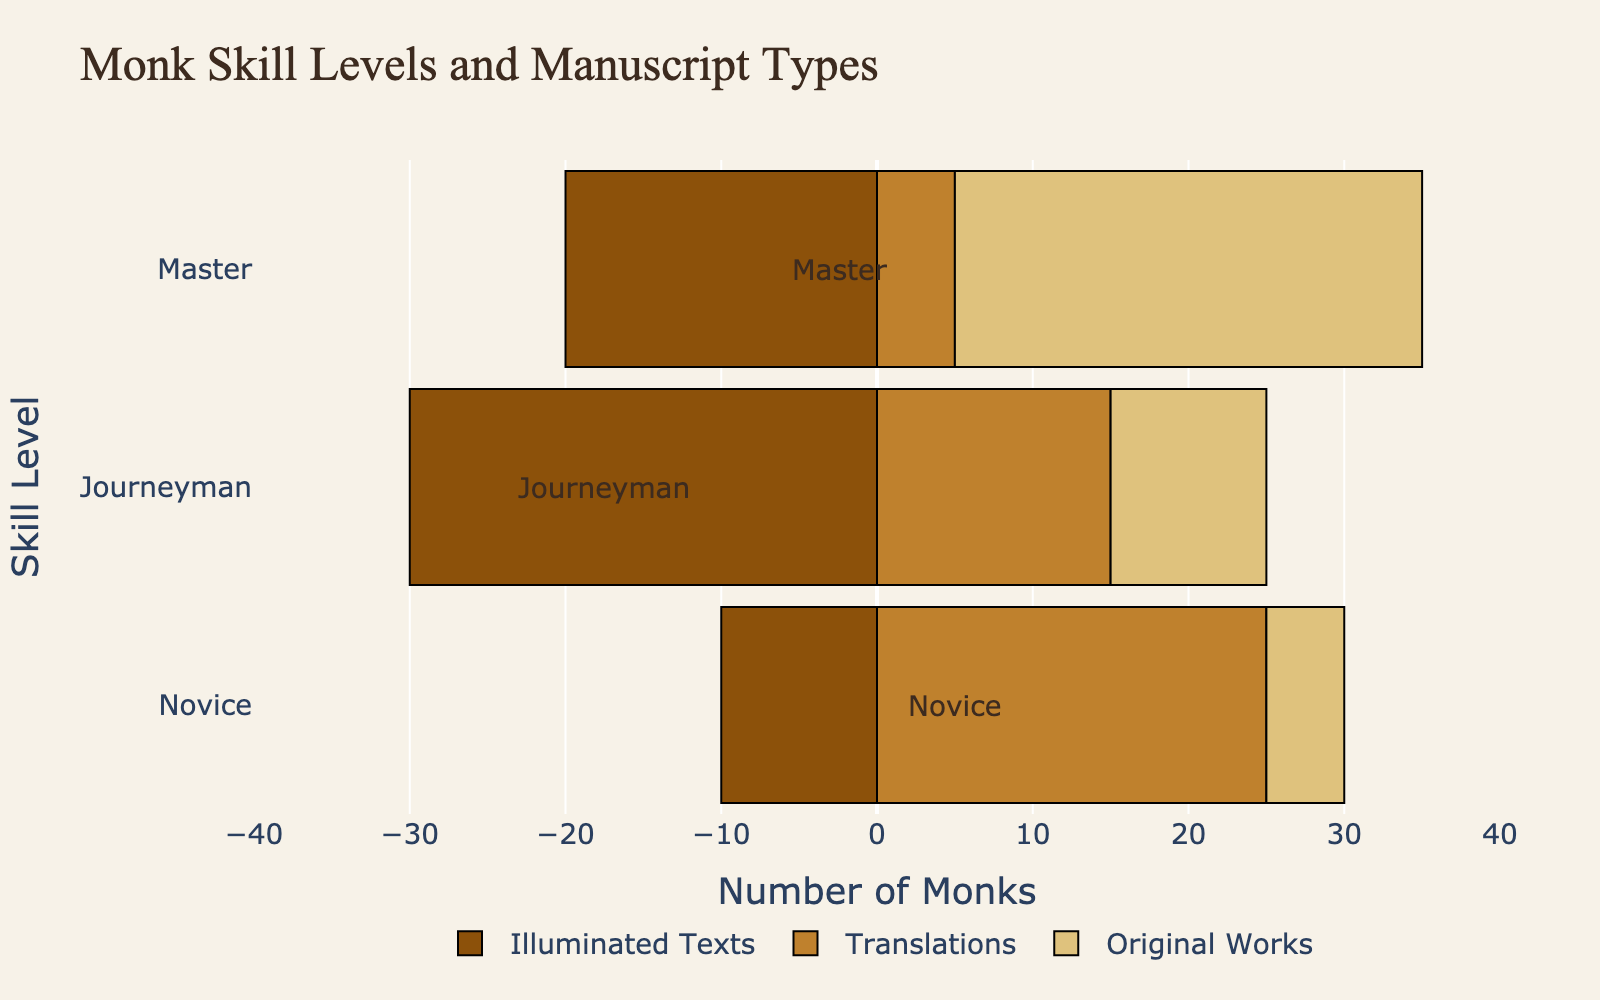Which skill level group works on the most original works? Looking at the bars for Original Works, the Master skill level has the longest bar, indicating they work on the most original works.
Answer: Master Among novices, which type of manuscript do they work on the most? For novices, the longest bar is for Translations, indicating it is the type of manuscript they work on the most.
Answer: Translations Comparing journeymen and masters, who works less on translations? The bar for Translations for Masters is shorter than that for Journeymen, indicating Masters work less on translations.
Answer: Masters How many monks in total work on illuminated texts? Sum the numbers for Illuminated Texts: 10 (Novice) + 30 (Journeyman) + 20 (Master) = 60 monks in total.
Answer: 60 What’s the difference in the number of monks working on translations between novices and journeymen? The number of monks working on Translations for novices is 25 and for journeymen is 15, so the difference is 25 - 15 = 10 monks.
Answer: 10 Which category has the smallest total number of monks across all skill levels? Summing the monks for each category: Illuminated Texts (10+30+20=60), Translations (25+15+5=45), Original Works (5+10+30=45). Translations and Original Works both have the smallest total of 45 monks.
Answer: Translations, Original Works What is the total number of monks working on original works and illuminated texts combined at the master level? For Masters: Original Works (30) + Illuminated Texts (20) = 50 monks.
Answer: 50 Which skill level equally divides their efforts between illuminated texts and original works? For Masters, the bar lengths for Illuminated Texts (20) and Original Works (30) combined with their roles in Translations indicate more balanced efforts divided across types, especially between these two.
Answer: Master In the journeyman skill level, what is the ratio of monks working on translations to monks working on original works? The number of monks for Translations in Journeyman is 15, and for Original Works is 10. Thus, the ratio is 15:10, which simplifies to 3:2.
Answer: 3:2 